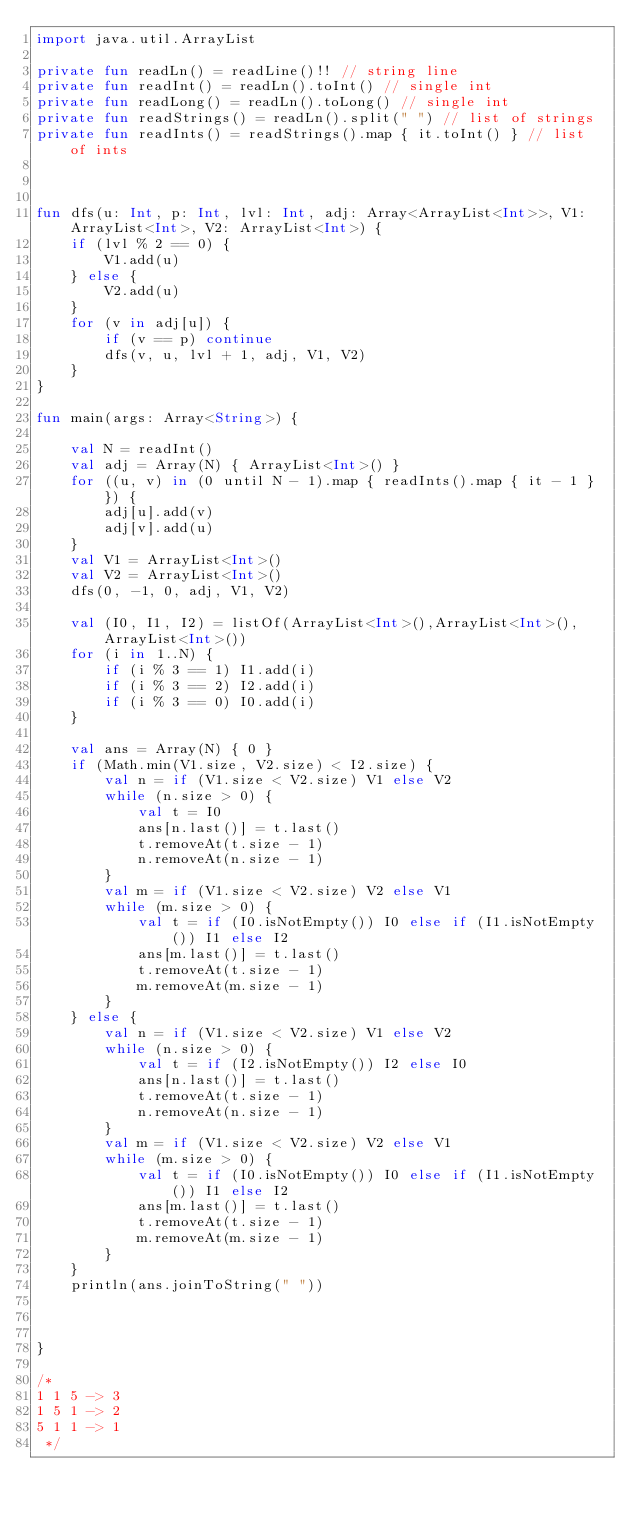Convert code to text. <code><loc_0><loc_0><loc_500><loc_500><_Kotlin_>import java.util.ArrayList

private fun readLn() = readLine()!! // string line
private fun readInt() = readLn().toInt() // single int
private fun readLong() = readLn().toLong() // single int
private fun readStrings() = readLn().split(" ") // list of strings
private fun readInts() = readStrings().map { it.toInt() } // list of ints



fun dfs(u: Int, p: Int, lvl: Int, adj: Array<ArrayList<Int>>, V1: ArrayList<Int>, V2: ArrayList<Int>) {
    if (lvl % 2 == 0) {
        V1.add(u)
    } else {
        V2.add(u)
    }
    for (v in adj[u]) {
        if (v == p) continue
        dfs(v, u, lvl + 1, adj, V1, V2)
    }
}

fun main(args: Array<String>) {

    val N = readInt()
    val adj = Array(N) { ArrayList<Int>() }
    for ((u, v) in (0 until N - 1).map { readInts().map { it - 1 } }) {
        adj[u].add(v)
        adj[v].add(u)
    }
    val V1 = ArrayList<Int>()
    val V2 = ArrayList<Int>()
    dfs(0, -1, 0, adj, V1, V2)

    val (I0, I1, I2) = listOf(ArrayList<Int>(),ArrayList<Int>(),ArrayList<Int>())
    for (i in 1..N) {
        if (i % 3 == 1) I1.add(i)
        if (i % 3 == 2) I2.add(i)
        if (i % 3 == 0) I0.add(i)
    }

    val ans = Array(N) { 0 }
    if (Math.min(V1.size, V2.size) < I2.size) {
        val n = if (V1.size < V2.size) V1 else V2
        while (n.size > 0) {
            val t = I0
            ans[n.last()] = t.last()
            t.removeAt(t.size - 1)
            n.removeAt(n.size - 1)
        }
        val m = if (V1.size < V2.size) V2 else V1
        while (m.size > 0) {
            val t = if (I0.isNotEmpty()) I0 else if (I1.isNotEmpty()) I1 else I2
            ans[m.last()] = t.last()
            t.removeAt(t.size - 1)
            m.removeAt(m.size - 1)
        }
    } else {
        val n = if (V1.size < V2.size) V1 else V2
        while (n.size > 0) {
            val t = if (I2.isNotEmpty()) I2 else I0
            ans[n.last()] = t.last()
            t.removeAt(t.size - 1)
            n.removeAt(n.size - 1)
        }
        val m = if (V1.size < V2.size) V2 else V1
        while (m.size > 0) {
            val t = if (I0.isNotEmpty()) I0 else if (I1.isNotEmpty()) I1 else I2
            ans[m.last()] = t.last()
            t.removeAt(t.size - 1)
            m.removeAt(m.size - 1)
        }
    }
    println(ans.joinToString(" "))



}

/*
1 1 5 -> 3
1 5 1 -> 2
5 1 1 -> 1
 */
</code> 